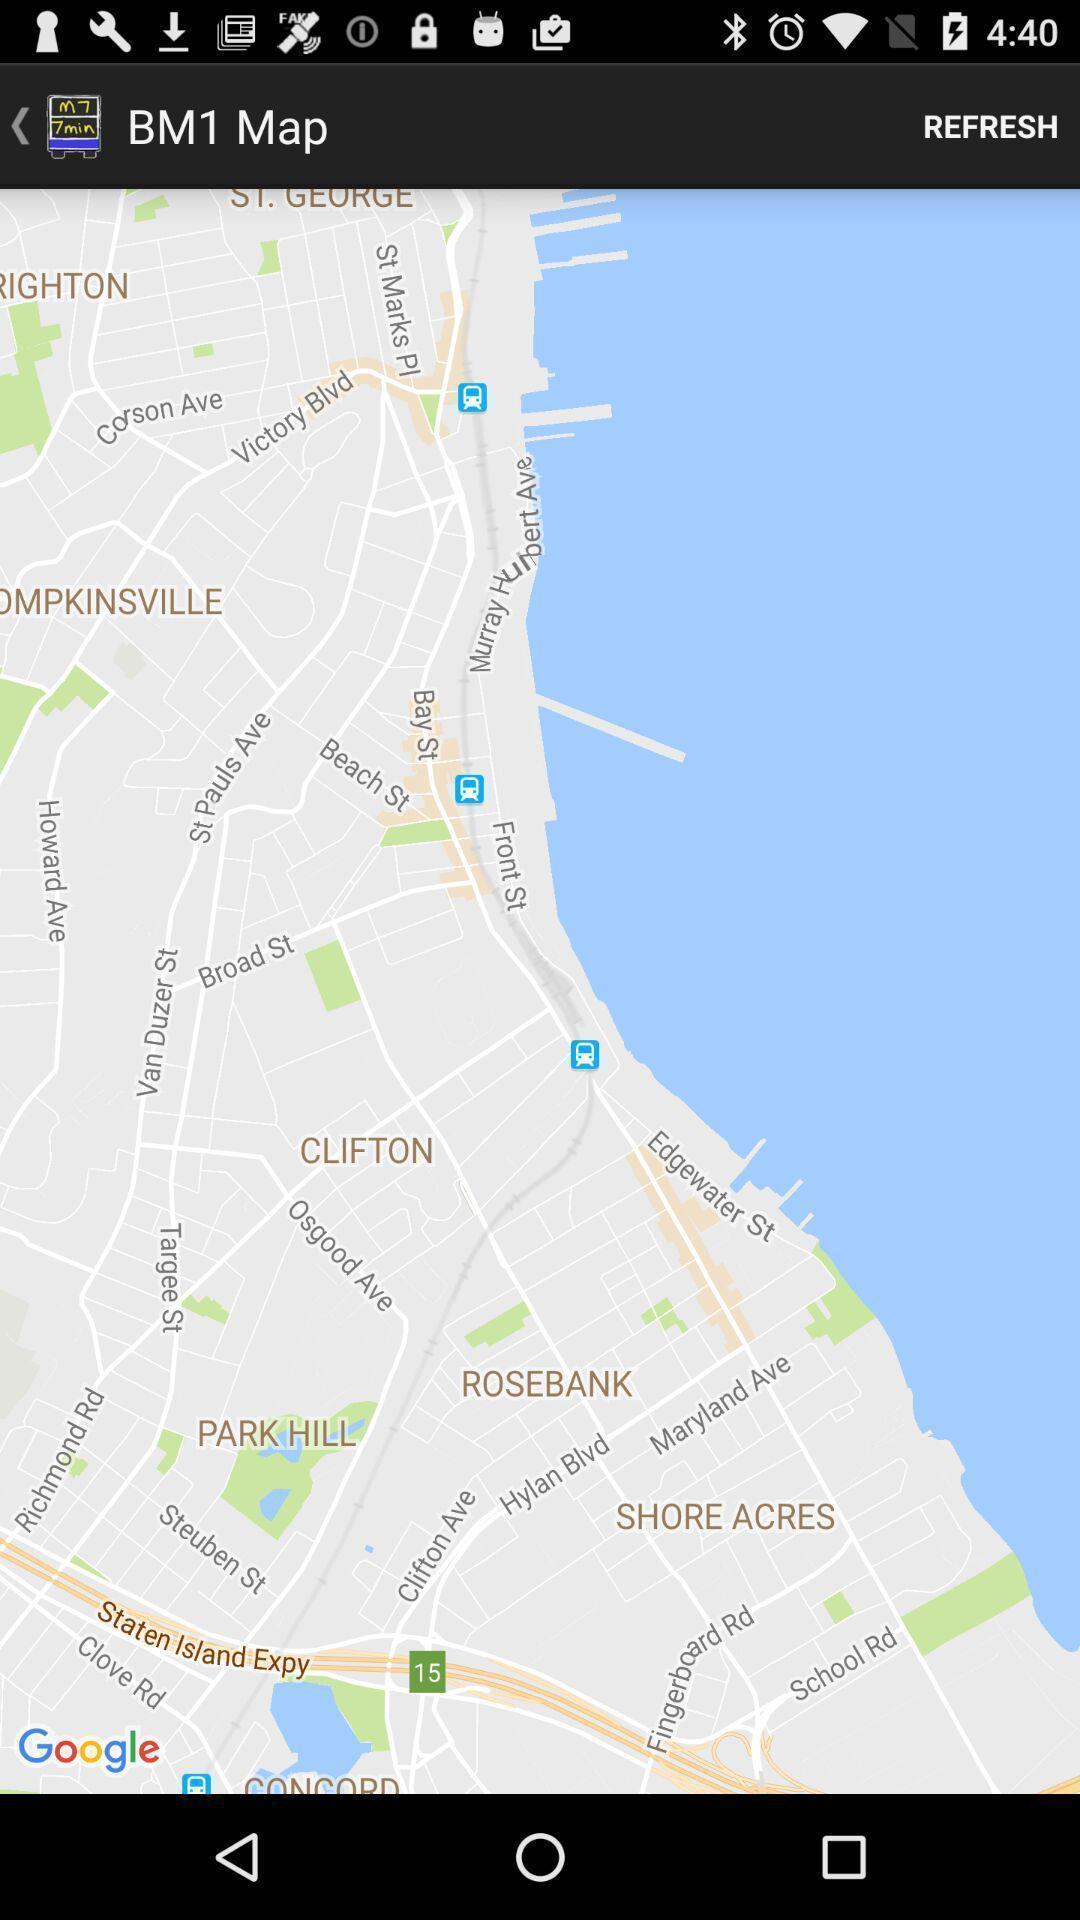Describe the content in this image. Screen shows a map for location. 